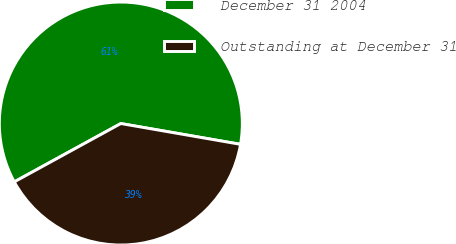Convert chart. <chart><loc_0><loc_0><loc_500><loc_500><pie_chart><fcel>December 31 2004<fcel>Outstanding at December 31<nl><fcel>60.71%<fcel>39.29%<nl></chart> 